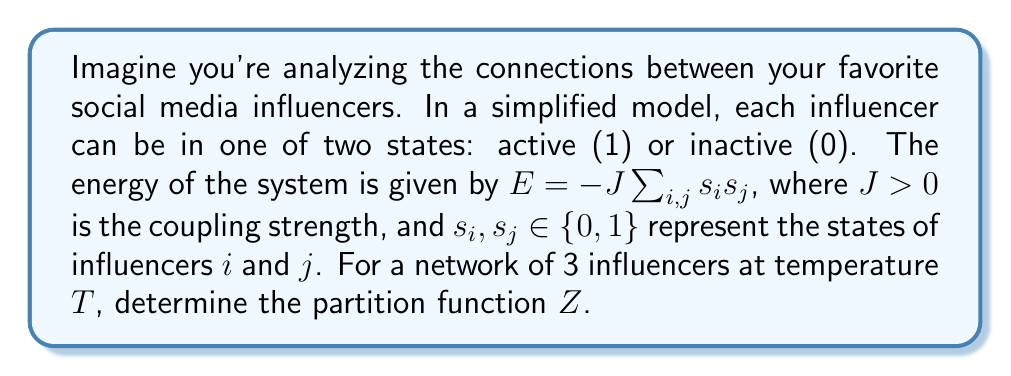Provide a solution to this math problem. Let's approach this step-by-step:

1) The partition function is defined as:
   $$Z = \sum_{\text{all states}} e^{-\beta E}$$
   where $\beta = \frac{1}{k_B T}$, $k_B$ is Boltzmann's constant.

2) For 3 influencers, we have $2^3 = 8$ possible states:
   (0,0,0), (0,0,1), (0,1,0), (1,0,0), (0,1,1), (1,0,1), (1,1,0), (1,1,1)

3) Let's calculate the energy for each state:
   - For (0,0,0): $E = 0$
   - For (0,0,1), (0,1,0), (1,0,0): $E = 0$
   - For (0,1,1), (1,0,1), (1,1,0): $E = -J$
   - For (1,1,1): $E = -3J$

4) Now, let's sum up the Boltzmann factors:
   $$Z = 1 + 3 + 3e^{\beta J} + e^{3\beta J}$$

5) We can factor this as:
   $$Z = (1 + e^{\beta J})^3 + 2(1 + e^{\beta J})$$

This is our final form of the partition function.
Answer: $Z = (1 + e^{\beta J})^3 + 2(1 + e^{\beta J})$ 